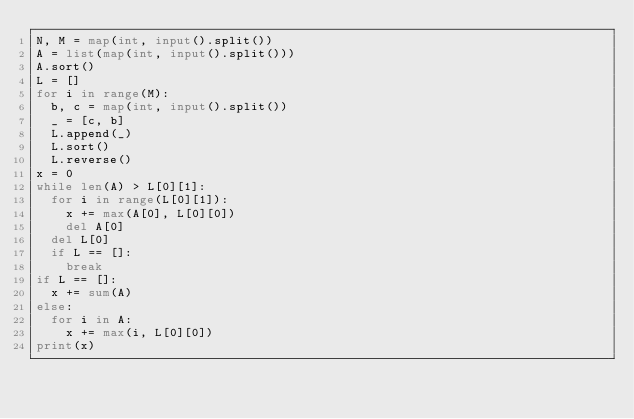<code> <loc_0><loc_0><loc_500><loc_500><_Python_>N, M = map(int, input().split())
A = list(map(int, input().split()))
A.sort()
L = []
for i in range(M):
	b, c = map(int, input().split())
	_ = [c, b]
	L.append(_)
	L.sort()
	L.reverse()
x = 0
while len(A) > L[0][1]:
	for i in range(L[0][1]):
		x += max(A[0], L[0][0])
		del A[0]
	del L[0]
	if L == []:
		break
if L == []:
	x += sum(A)
else:
	for i in A:
		x += max(i, L[0][0])
print(x)</code> 